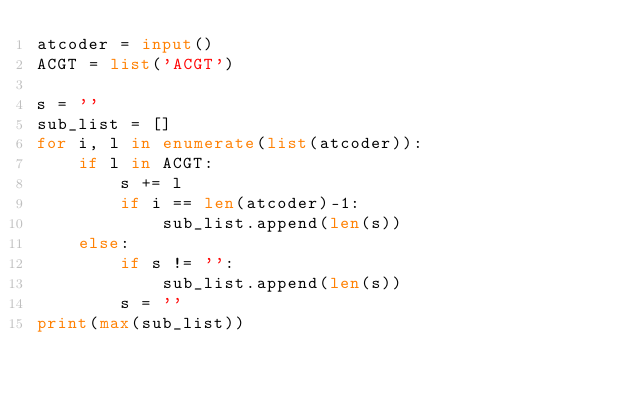Convert code to text. <code><loc_0><loc_0><loc_500><loc_500><_Python_>atcoder = input()
ACGT = list('ACGT')

s = ''
sub_list = []
for i, l in enumerate(list(atcoder)):
    if l in ACGT:
        s += l
        if i == len(atcoder)-1:
            sub_list.append(len(s))
    else:
        if s != '':
            sub_list.append(len(s))
        s = ''
print(max(sub_list))
</code> 